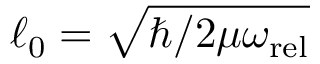Convert formula to latex. <formula><loc_0><loc_0><loc_500><loc_500>\ell _ { 0 } = \sqrt { \hbar { / } 2 \mu \omega _ { r e l } }</formula> 